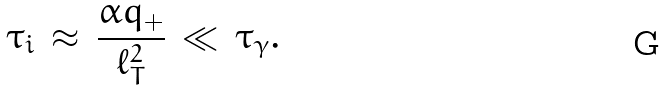<formula> <loc_0><loc_0><loc_500><loc_500>\tau _ { i } \, \approx \, \frac { \alpha q _ { + } } { \ell _ { T } ^ { 2 } } \, \ll \, \tau _ { \gamma } .</formula> 